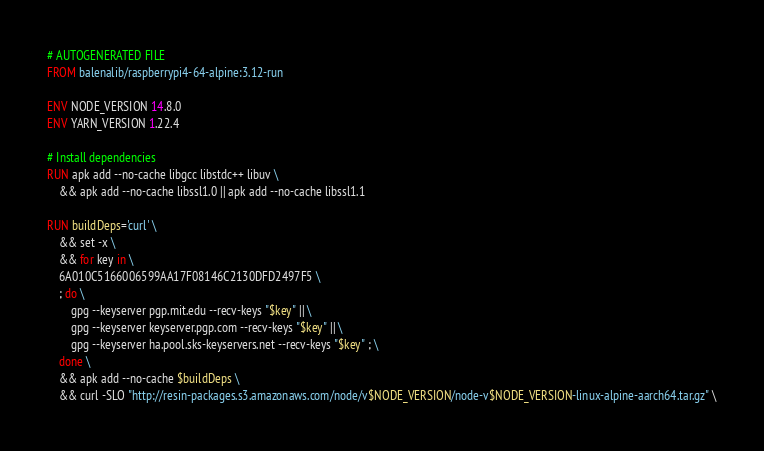Convert code to text. <code><loc_0><loc_0><loc_500><loc_500><_Dockerfile_># AUTOGENERATED FILE
FROM balenalib/raspberrypi4-64-alpine:3.12-run

ENV NODE_VERSION 14.8.0
ENV YARN_VERSION 1.22.4

# Install dependencies
RUN apk add --no-cache libgcc libstdc++ libuv \
	&& apk add --no-cache libssl1.0 || apk add --no-cache libssl1.1

RUN buildDeps='curl' \
	&& set -x \
	&& for key in \
	6A010C5166006599AA17F08146C2130DFD2497F5 \
	; do \
		gpg --keyserver pgp.mit.edu --recv-keys "$key" || \
		gpg --keyserver keyserver.pgp.com --recv-keys "$key" || \
		gpg --keyserver ha.pool.sks-keyservers.net --recv-keys "$key" ; \
	done \
	&& apk add --no-cache $buildDeps \
	&& curl -SLO "http://resin-packages.s3.amazonaws.com/node/v$NODE_VERSION/node-v$NODE_VERSION-linux-alpine-aarch64.tar.gz" \</code> 